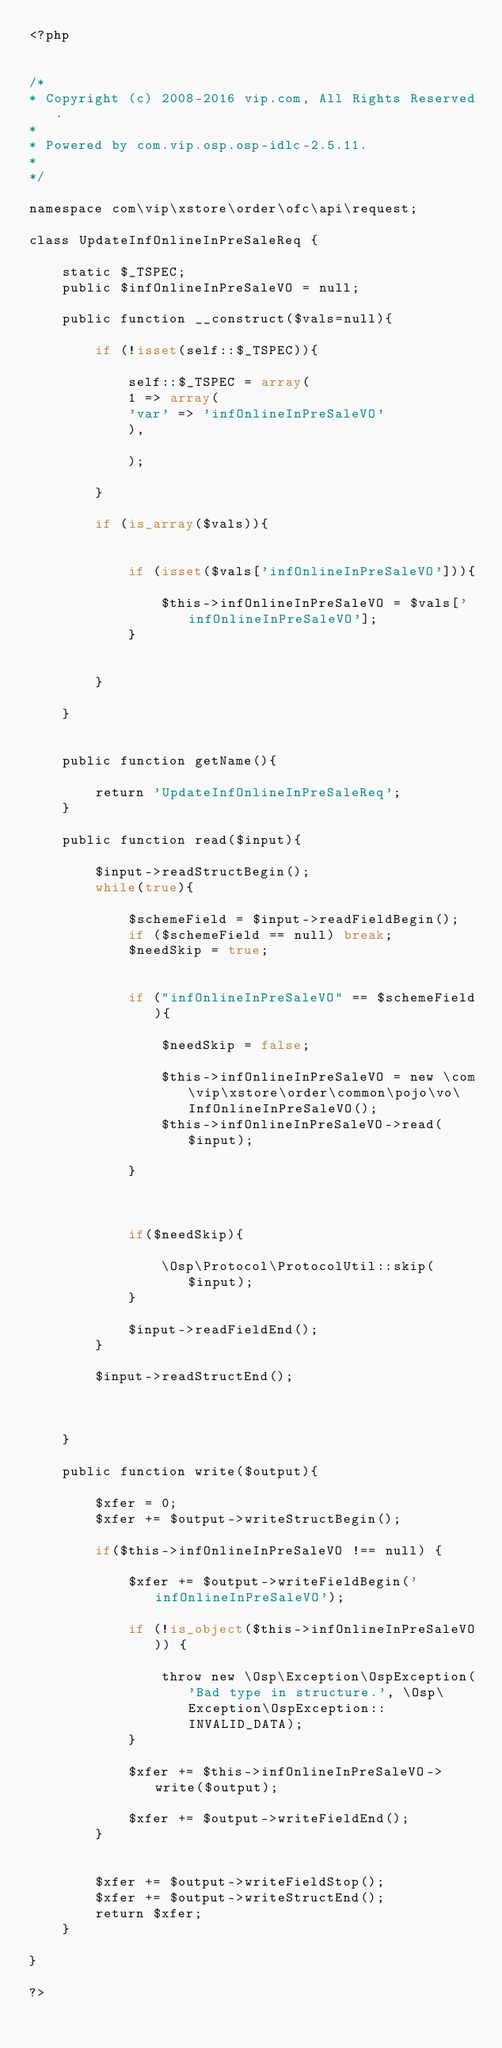<code> <loc_0><loc_0><loc_500><loc_500><_PHP_><?php


/*
* Copyright (c) 2008-2016 vip.com, All Rights Reserved.
*
* Powered by com.vip.osp.osp-idlc-2.5.11.
*
*/

namespace com\vip\xstore\order\ofc\api\request;

class UpdateInfOnlineInPreSaleReq {
	
	static $_TSPEC;
	public $infOnlineInPreSaleVO = null;
	
	public function __construct($vals=null){
		
		if (!isset(self::$_TSPEC)){
			
			self::$_TSPEC = array(
			1 => array(
			'var' => 'infOnlineInPreSaleVO'
			),
			
			);
			
		}
		
		if (is_array($vals)){
			
			
			if (isset($vals['infOnlineInPreSaleVO'])){
				
				$this->infOnlineInPreSaleVO = $vals['infOnlineInPreSaleVO'];
			}
			
			
		}
		
	}
	
	
	public function getName(){
		
		return 'UpdateInfOnlineInPreSaleReq';
	}
	
	public function read($input){
		
		$input->readStructBegin();
		while(true){
			
			$schemeField = $input->readFieldBegin();
			if ($schemeField == null) break;
			$needSkip = true;
			
			
			if ("infOnlineInPreSaleVO" == $schemeField){
				
				$needSkip = false;
				
				$this->infOnlineInPreSaleVO = new \com\vip\xstore\order\common\pojo\vo\InfOnlineInPreSaleVO();
				$this->infOnlineInPreSaleVO->read($input);
				
			}
			
			
			
			if($needSkip){
				
				\Osp\Protocol\ProtocolUtil::skip($input);
			}
			
			$input->readFieldEnd();
		}
		
		$input->readStructEnd();
		
		
		
	}
	
	public function write($output){
		
		$xfer = 0;
		$xfer += $output->writeStructBegin();
		
		if($this->infOnlineInPreSaleVO !== null) {
			
			$xfer += $output->writeFieldBegin('infOnlineInPreSaleVO');
			
			if (!is_object($this->infOnlineInPreSaleVO)) {
				
				throw new \Osp\Exception\OspException('Bad type in structure.', \Osp\Exception\OspException::INVALID_DATA);
			}
			
			$xfer += $this->infOnlineInPreSaleVO->write($output);
			
			$xfer += $output->writeFieldEnd();
		}
		
		
		$xfer += $output->writeFieldStop();
		$xfer += $output->writeStructEnd();
		return $xfer;
	}
	
}

?></code> 